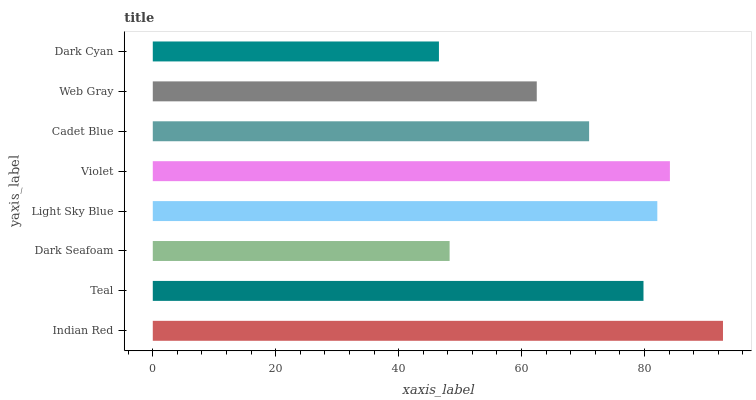Is Dark Cyan the minimum?
Answer yes or no. Yes. Is Indian Red the maximum?
Answer yes or no. Yes. Is Teal the minimum?
Answer yes or no. No. Is Teal the maximum?
Answer yes or no. No. Is Indian Red greater than Teal?
Answer yes or no. Yes. Is Teal less than Indian Red?
Answer yes or no. Yes. Is Teal greater than Indian Red?
Answer yes or no. No. Is Indian Red less than Teal?
Answer yes or no. No. Is Teal the high median?
Answer yes or no. Yes. Is Cadet Blue the low median?
Answer yes or no. Yes. Is Indian Red the high median?
Answer yes or no. No. Is Violet the low median?
Answer yes or no. No. 